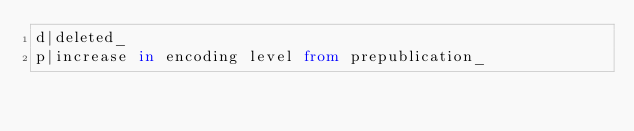Convert code to text. <code><loc_0><loc_0><loc_500><loc_500><_SQL_>d|deleted_ 
p|increase in encoding level from prepublication_</code> 